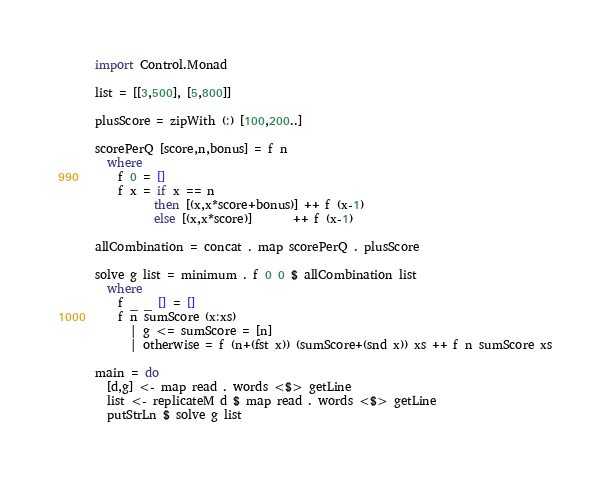<code> <loc_0><loc_0><loc_500><loc_500><_Haskell_>import Control.Monad

list = [[3,500], [5,800]]

plusScore = zipWith (:) [100,200..]

scorePerQ [score,n,bonus] = f n
  where
    f 0 = []
    f x = if x == n
          then [(x,x*score+bonus)] ++ f (x-1)
          else [(x,x*score)]       ++ f (x-1)

allCombination = concat . map scorePerQ . plusScore

solve g list = minimum . f 0 0 $ allCombination list
  where
    f _ _ [] = []
    f n sumScore (x:xs)
      | g <= sumScore = [n]
      | otherwise = f (n+(fst x)) (sumScore+(snd x)) xs ++ f n sumScore xs

main = do
  [d,g] <- map read . words <$> getLine
  list <- replicateM d $ map read . words <$> getLine
  putStrLn $ solve g list
</code> 